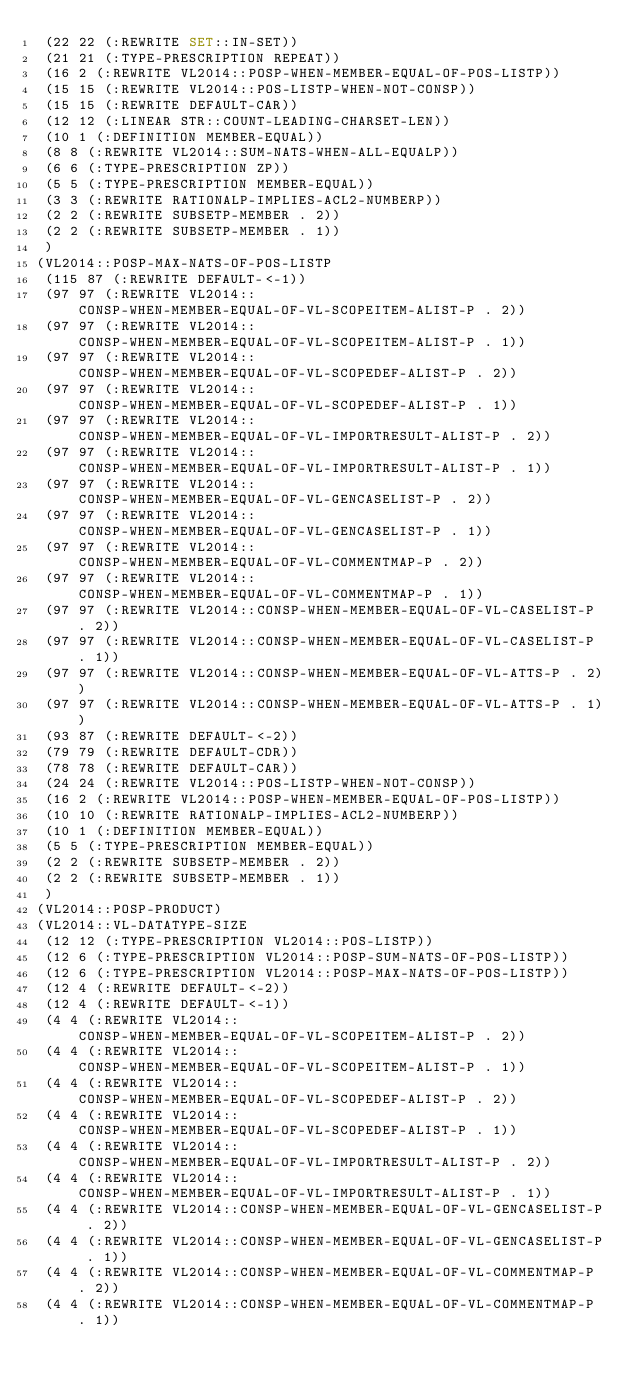Convert code to text. <code><loc_0><loc_0><loc_500><loc_500><_Lisp_> (22 22 (:REWRITE SET::IN-SET))
 (21 21 (:TYPE-PRESCRIPTION REPEAT))
 (16 2 (:REWRITE VL2014::POSP-WHEN-MEMBER-EQUAL-OF-POS-LISTP))
 (15 15 (:REWRITE VL2014::POS-LISTP-WHEN-NOT-CONSP))
 (15 15 (:REWRITE DEFAULT-CAR))
 (12 12 (:LINEAR STR::COUNT-LEADING-CHARSET-LEN))
 (10 1 (:DEFINITION MEMBER-EQUAL))
 (8 8 (:REWRITE VL2014::SUM-NATS-WHEN-ALL-EQUALP))
 (6 6 (:TYPE-PRESCRIPTION ZP))
 (5 5 (:TYPE-PRESCRIPTION MEMBER-EQUAL))
 (3 3 (:REWRITE RATIONALP-IMPLIES-ACL2-NUMBERP))
 (2 2 (:REWRITE SUBSETP-MEMBER . 2))
 (2 2 (:REWRITE SUBSETP-MEMBER . 1))
 )
(VL2014::POSP-MAX-NATS-OF-POS-LISTP
 (115 87 (:REWRITE DEFAULT-<-1))
 (97 97 (:REWRITE VL2014::CONSP-WHEN-MEMBER-EQUAL-OF-VL-SCOPEITEM-ALIST-P . 2))
 (97 97 (:REWRITE VL2014::CONSP-WHEN-MEMBER-EQUAL-OF-VL-SCOPEITEM-ALIST-P . 1))
 (97 97 (:REWRITE VL2014::CONSP-WHEN-MEMBER-EQUAL-OF-VL-SCOPEDEF-ALIST-P . 2))
 (97 97 (:REWRITE VL2014::CONSP-WHEN-MEMBER-EQUAL-OF-VL-SCOPEDEF-ALIST-P . 1))
 (97 97 (:REWRITE VL2014::CONSP-WHEN-MEMBER-EQUAL-OF-VL-IMPORTRESULT-ALIST-P . 2))
 (97 97 (:REWRITE VL2014::CONSP-WHEN-MEMBER-EQUAL-OF-VL-IMPORTRESULT-ALIST-P . 1))
 (97 97 (:REWRITE VL2014::CONSP-WHEN-MEMBER-EQUAL-OF-VL-GENCASELIST-P . 2))
 (97 97 (:REWRITE VL2014::CONSP-WHEN-MEMBER-EQUAL-OF-VL-GENCASELIST-P . 1))
 (97 97 (:REWRITE VL2014::CONSP-WHEN-MEMBER-EQUAL-OF-VL-COMMENTMAP-P . 2))
 (97 97 (:REWRITE VL2014::CONSP-WHEN-MEMBER-EQUAL-OF-VL-COMMENTMAP-P . 1))
 (97 97 (:REWRITE VL2014::CONSP-WHEN-MEMBER-EQUAL-OF-VL-CASELIST-P . 2))
 (97 97 (:REWRITE VL2014::CONSP-WHEN-MEMBER-EQUAL-OF-VL-CASELIST-P . 1))
 (97 97 (:REWRITE VL2014::CONSP-WHEN-MEMBER-EQUAL-OF-VL-ATTS-P . 2))
 (97 97 (:REWRITE VL2014::CONSP-WHEN-MEMBER-EQUAL-OF-VL-ATTS-P . 1))
 (93 87 (:REWRITE DEFAULT-<-2))
 (79 79 (:REWRITE DEFAULT-CDR))
 (78 78 (:REWRITE DEFAULT-CAR))
 (24 24 (:REWRITE VL2014::POS-LISTP-WHEN-NOT-CONSP))
 (16 2 (:REWRITE VL2014::POSP-WHEN-MEMBER-EQUAL-OF-POS-LISTP))
 (10 10 (:REWRITE RATIONALP-IMPLIES-ACL2-NUMBERP))
 (10 1 (:DEFINITION MEMBER-EQUAL))
 (5 5 (:TYPE-PRESCRIPTION MEMBER-EQUAL))
 (2 2 (:REWRITE SUBSETP-MEMBER . 2))
 (2 2 (:REWRITE SUBSETP-MEMBER . 1))
 )
(VL2014::POSP-PRODUCT)
(VL2014::VL-DATATYPE-SIZE
 (12 12 (:TYPE-PRESCRIPTION VL2014::POS-LISTP))
 (12 6 (:TYPE-PRESCRIPTION VL2014::POSP-SUM-NATS-OF-POS-LISTP))
 (12 6 (:TYPE-PRESCRIPTION VL2014::POSP-MAX-NATS-OF-POS-LISTP))
 (12 4 (:REWRITE DEFAULT-<-2))
 (12 4 (:REWRITE DEFAULT-<-1))
 (4 4 (:REWRITE VL2014::CONSP-WHEN-MEMBER-EQUAL-OF-VL-SCOPEITEM-ALIST-P . 2))
 (4 4 (:REWRITE VL2014::CONSP-WHEN-MEMBER-EQUAL-OF-VL-SCOPEITEM-ALIST-P . 1))
 (4 4 (:REWRITE VL2014::CONSP-WHEN-MEMBER-EQUAL-OF-VL-SCOPEDEF-ALIST-P . 2))
 (4 4 (:REWRITE VL2014::CONSP-WHEN-MEMBER-EQUAL-OF-VL-SCOPEDEF-ALIST-P . 1))
 (4 4 (:REWRITE VL2014::CONSP-WHEN-MEMBER-EQUAL-OF-VL-IMPORTRESULT-ALIST-P . 2))
 (4 4 (:REWRITE VL2014::CONSP-WHEN-MEMBER-EQUAL-OF-VL-IMPORTRESULT-ALIST-P . 1))
 (4 4 (:REWRITE VL2014::CONSP-WHEN-MEMBER-EQUAL-OF-VL-GENCASELIST-P . 2))
 (4 4 (:REWRITE VL2014::CONSP-WHEN-MEMBER-EQUAL-OF-VL-GENCASELIST-P . 1))
 (4 4 (:REWRITE VL2014::CONSP-WHEN-MEMBER-EQUAL-OF-VL-COMMENTMAP-P . 2))
 (4 4 (:REWRITE VL2014::CONSP-WHEN-MEMBER-EQUAL-OF-VL-COMMENTMAP-P . 1))</code> 